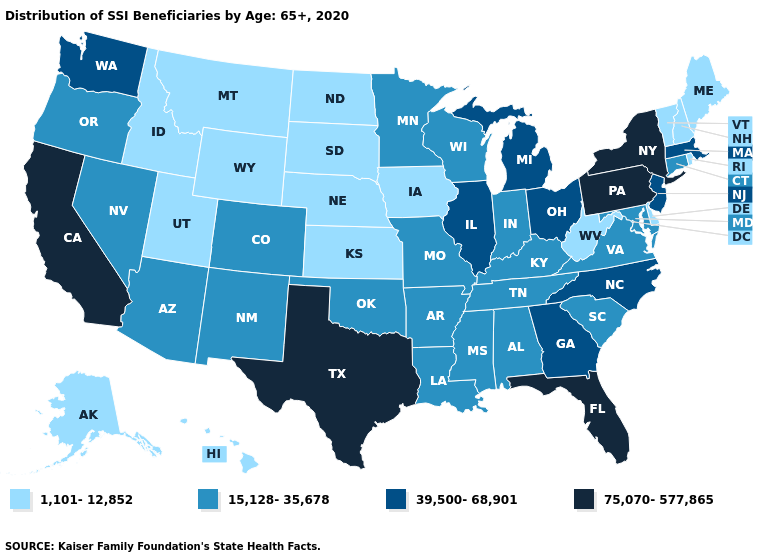Among the states that border Kansas , does Colorado have the lowest value?
Concise answer only. No. Name the states that have a value in the range 39,500-68,901?
Keep it brief. Georgia, Illinois, Massachusetts, Michigan, New Jersey, North Carolina, Ohio, Washington. Name the states that have a value in the range 15,128-35,678?
Concise answer only. Alabama, Arizona, Arkansas, Colorado, Connecticut, Indiana, Kentucky, Louisiana, Maryland, Minnesota, Mississippi, Missouri, Nevada, New Mexico, Oklahoma, Oregon, South Carolina, Tennessee, Virginia, Wisconsin. Does Minnesota have the highest value in the MidWest?
Write a very short answer. No. Name the states that have a value in the range 1,101-12,852?
Concise answer only. Alaska, Delaware, Hawaii, Idaho, Iowa, Kansas, Maine, Montana, Nebraska, New Hampshire, North Dakota, Rhode Island, South Dakota, Utah, Vermont, West Virginia, Wyoming. Name the states that have a value in the range 75,070-577,865?
Concise answer only. California, Florida, New York, Pennsylvania, Texas. Which states have the lowest value in the West?
Concise answer only. Alaska, Hawaii, Idaho, Montana, Utah, Wyoming. Name the states that have a value in the range 1,101-12,852?
Quick response, please. Alaska, Delaware, Hawaii, Idaho, Iowa, Kansas, Maine, Montana, Nebraska, New Hampshire, North Dakota, Rhode Island, South Dakota, Utah, Vermont, West Virginia, Wyoming. Does Hawaii have the lowest value in the West?
Keep it brief. Yes. Name the states that have a value in the range 39,500-68,901?
Concise answer only. Georgia, Illinois, Massachusetts, Michigan, New Jersey, North Carolina, Ohio, Washington. Name the states that have a value in the range 1,101-12,852?
Give a very brief answer. Alaska, Delaware, Hawaii, Idaho, Iowa, Kansas, Maine, Montana, Nebraska, New Hampshire, North Dakota, Rhode Island, South Dakota, Utah, Vermont, West Virginia, Wyoming. What is the value of Kansas?
Keep it brief. 1,101-12,852. Does California have the highest value in the West?
Concise answer only. Yes. How many symbols are there in the legend?
Give a very brief answer. 4. What is the value of Mississippi?
Keep it brief. 15,128-35,678. 